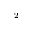<formula> <loc_0><loc_0><loc_500><loc_500>^ { - 2 }</formula> 